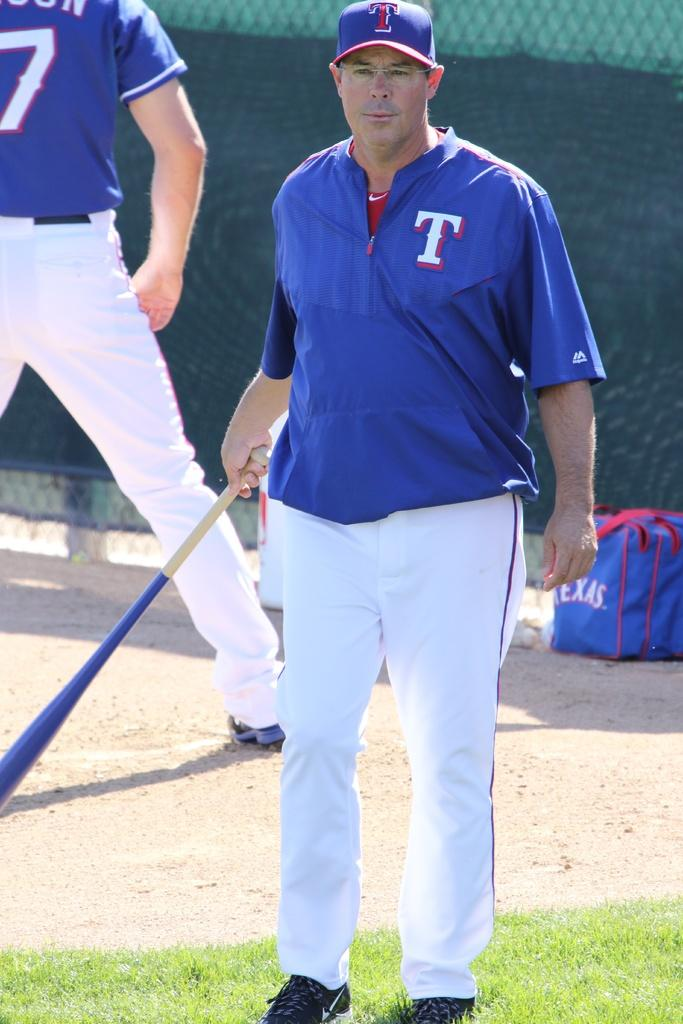<image>
Present a compact description of the photo's key features. A man in a Texas baseball uniform stands holding a bat in front of another man with 7 on the back of his uniform. 